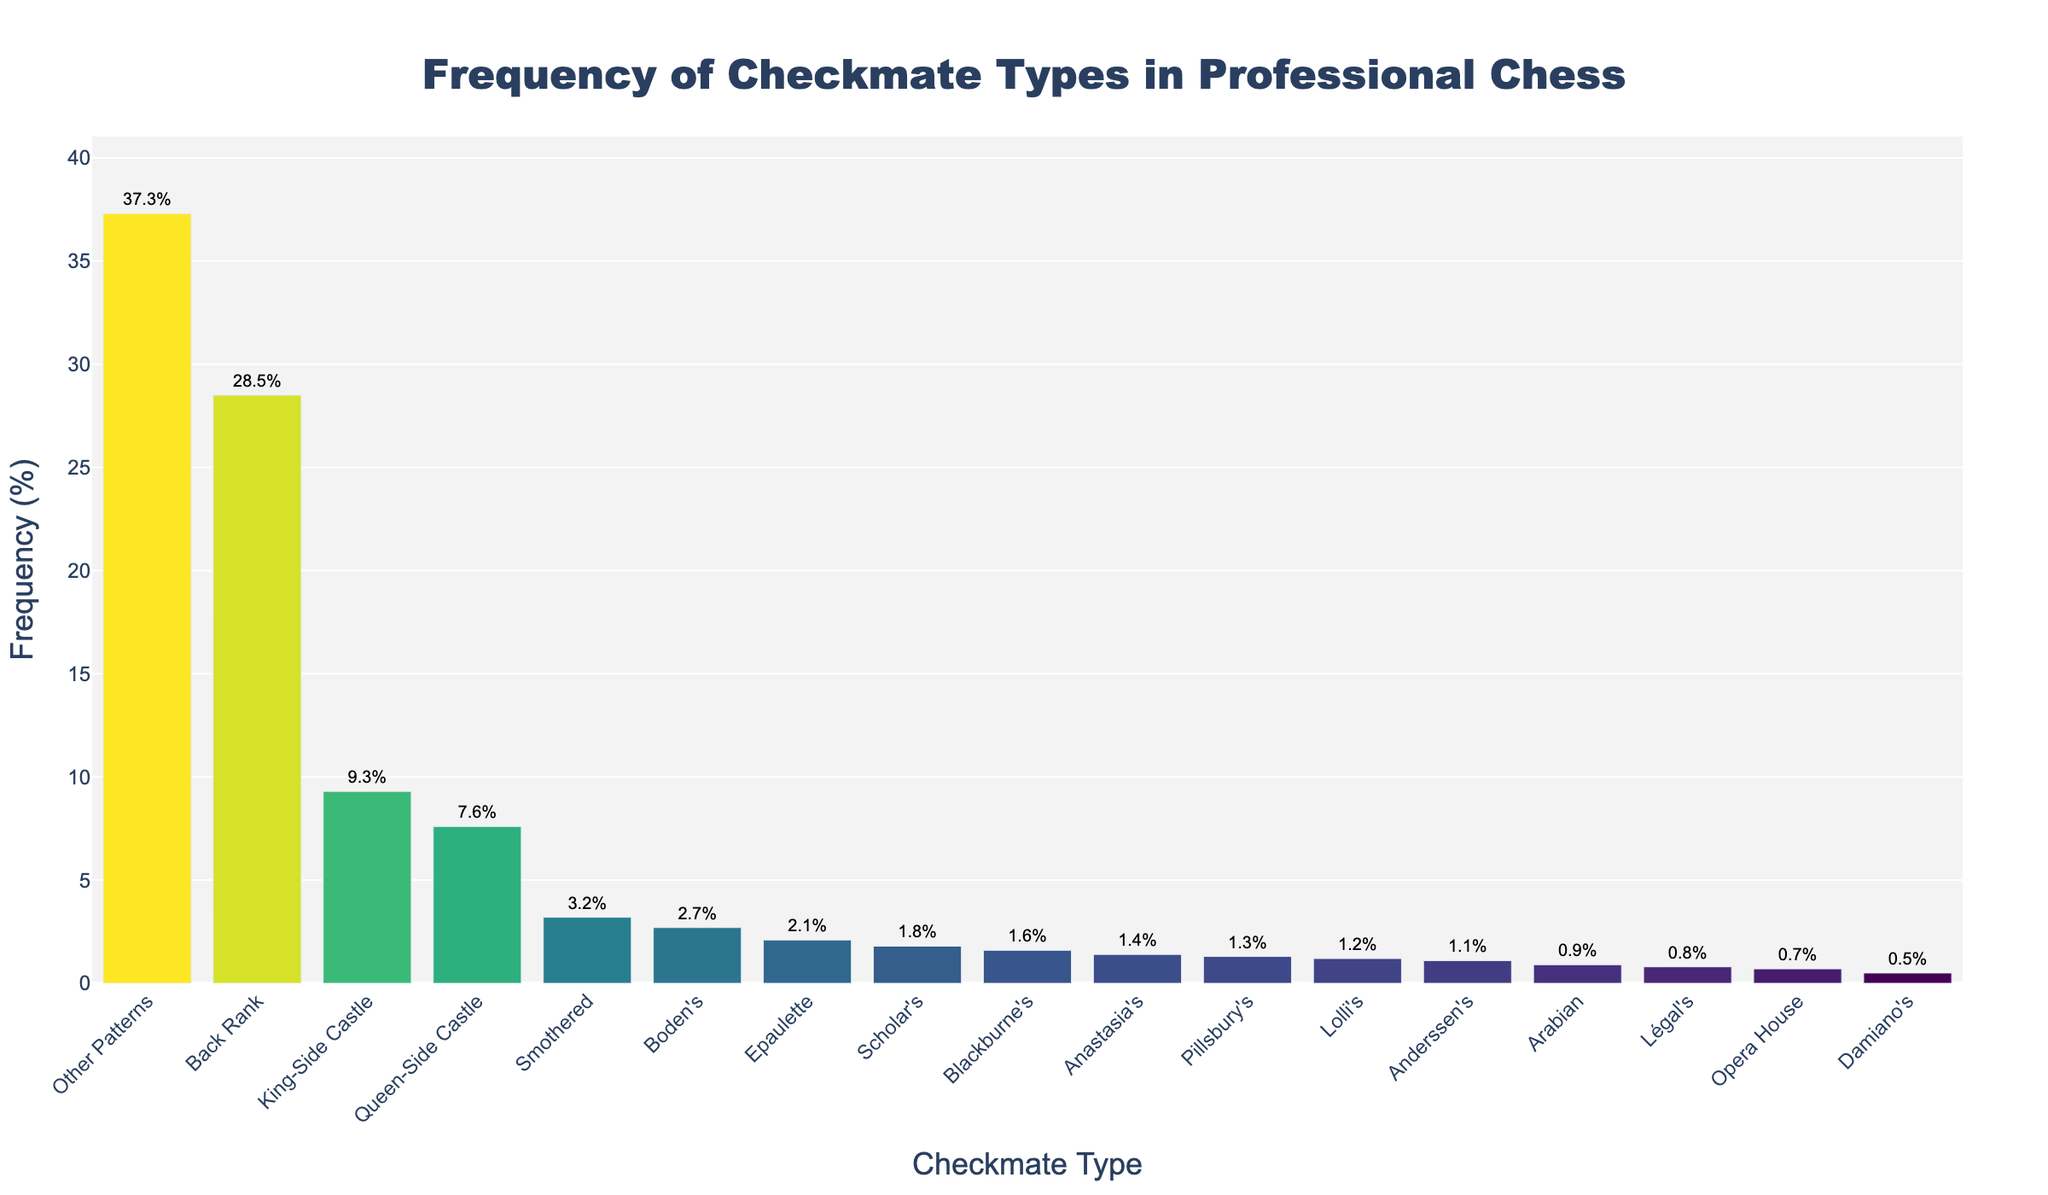What's the most common type of checkmate in professional chess games? The tallest bar represents the checkmate type with the highest frequency. By examining the figure, it's clear that the 'Back Rank' checkmate type has the tallest bar.
Answer: Back Rank Which checkmate type has a higher frequency: 'Smothered' or 'Boden's'? Compare the heights of the bars for 'Smothered' and 'Boden's'. The 'Smothered' bar is taller than the 'Boden's' bar, indicating a higher frequency.
Answer: Smothered What is the total frequency percentage for 'Queen-Side Castle' and 'King-Side Castle' checkmates combined? Add the frequency percentages of 'Queen-Side Castle' (7.6%) and 'King-Side Castle' (9.3%) checkmates together: 7.6 + 9.3 = 16.9%.
Answer: 16.9 How many checkmate types have a frequency below 1%? Count the bars with frequencies below 1%: Arabian (0.9%), Légal's (0.8%), Pillsbury's (0.8%), Opera House (0.7%), Damiano's (0.5%).
Answer: 5 Which checkmate type is nearly three times as common as 'Scholar's' checkmate? Find 'Scholar's' frequency (1.8%) and look for another with about three times this frequency. 'King-Side Castle' has a frequency of 9.3%, which is a little more than three times 'Scholar's'.
Answer: King-Side Castle What is the difference in frequency between 'Back Rank' and 'Other Patterns' checkmate types? Subtract the frequency of 'Other Patterns' (37.3%) from 'Back Rank' (28.5%): 37.3 - 28.5 = 8.8%.
Answer: 8.8 Which checkmate types have a frequency between 1% and 2%? Identify the bars within the 1% to 2% range. They are: Scholar's (1.8%), Anastasia's (1.4%), Anderssen's (1.1%), Lolli's (1.2%), Pillsbury's (1.3%), Blackburne's (1.6%).
Answer: Scholar's, Anastasia's, Anderssen's, Lolli's, Pillsbury's, Blackburne's What percentage of checkmates belong to 'Other Patterns'? Find and note the frequency associated with 'Other Patterns'. The bar shows 37.3%.
Answer: 37.3 Is the frequency of 'Smothered' checkmate type more than two times the frequency of 'Epaulette' checkmate type? If so, by how much? Check 'Smothered' (3.2%) and 'Epaulette' (2.1%) frequencies. Yes, 3.2 is more than twice 2.1. Find the difference: 3.2 - 2.1 = 1.1%.
Answer: Yes, by 1.1% 